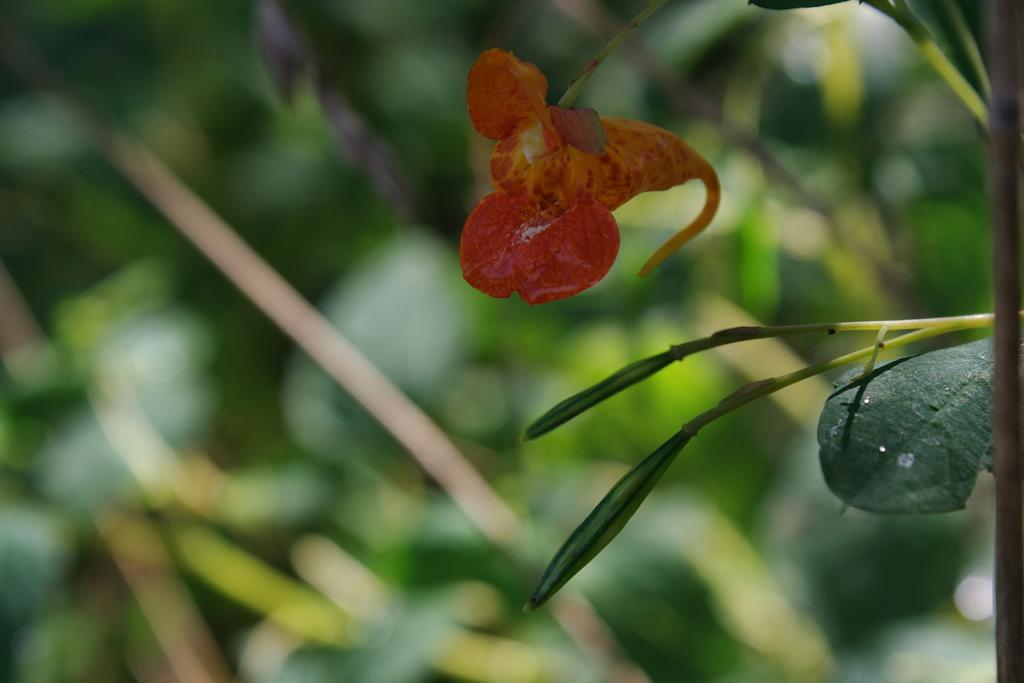What is the main subject of the image? There is a flower in the image. What else can be seen in the image besides the flower? There are leaves in the image. Can you describe the background of the image? The background of the image is blurred. What type of oven is visible in the image? There is no oven present in the image; it features a flower and leaves. What stage of development is the flower in the image? The stage of development of the flower cannot be determined from the image alone, as it only shows the flower and leaves. 